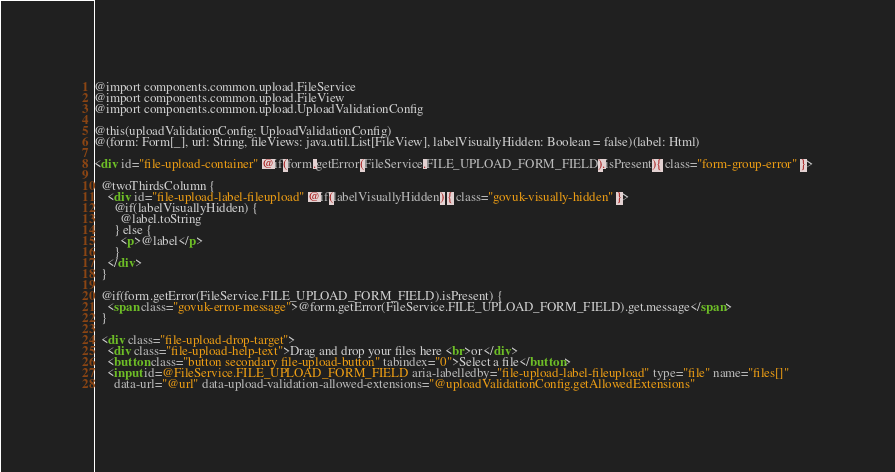Convert code to text. <code><loc_0><loc_0><loc_500><loc_500><_HTML_>@import components.common.upload.FileService
@import components.common.upload.FileView
@import components.common.upload.UploadValidationConfig

@this(uploadValidationConfig: UploadValidationConfig)
@(form: Form[_], url: String, fileViews: java.util.List[FileView], labelVisuallyHidden: Boolean = false)(label: Html)

<div id="file-upload-container" @if(form.getError(FileService.FILE_UPLOAD_FORM_FIELD).isPresent){ class="form-group-error" }>

  @twoThirdsColumn {
    <div id="file-upload-label-fileupload" @if(labelVisuallyHidden) { class="govuk-visually-hidden" }>
      @if(labelVisuallyHidden) {
        @label.toString
      } else {
        <p>@label</p>
      }
    </div>
  }

  @if(form.getError(FileService.FILE_UPLOAD_FORM_FIELD).isPresent) {
    <span class="govuk-error-message">@form.getError(FileService.FILE_UPLOAD_FORM_FIELD).get.message</span>
  }

  <div class="file-upload-drop-target">
    <div class="file-upload-help-text">Drag and drop your files here <br>or</div>
    <button class="button secondary file-upload-button" tabindex="0">Select a file</button>
    <input id=@FileService.FILE_UPLOAD_FORM_FIELD aria-labelledby="file-upload-label-fileupload" type="file" name="files[]"
      data-url="@url" data-upload-validation-allowed-extensions="@uploadValidationConfig.getAllowedExtensions"</code> 